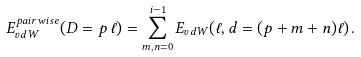Convert formula to latex. <formula><loc_0><loc_0><loc_500><loc_500>E ^ { p a i r w i s e } _ { v d W } ( D = p \, \ell ) = \sum _ { m , n = 0 } ^ { i - 1 } E _ { v d W } ( \ell , d = ( p + m + n ) \ell ) \, .</formula> 